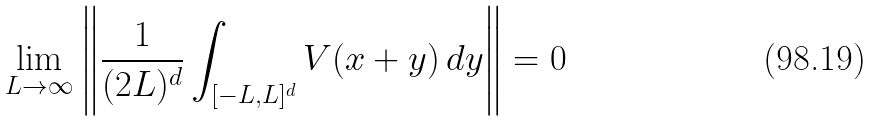<formula> <loc_0><loc_0><loc_500><loc_500>\lim _ { L \to \infty } \left \| \frac { 1 } { ( 2 L ) ^ { d } } \int _ { [ - L , L ] ^ { d } } V ( x + y ) \, d y \right \| = 0</formula> 